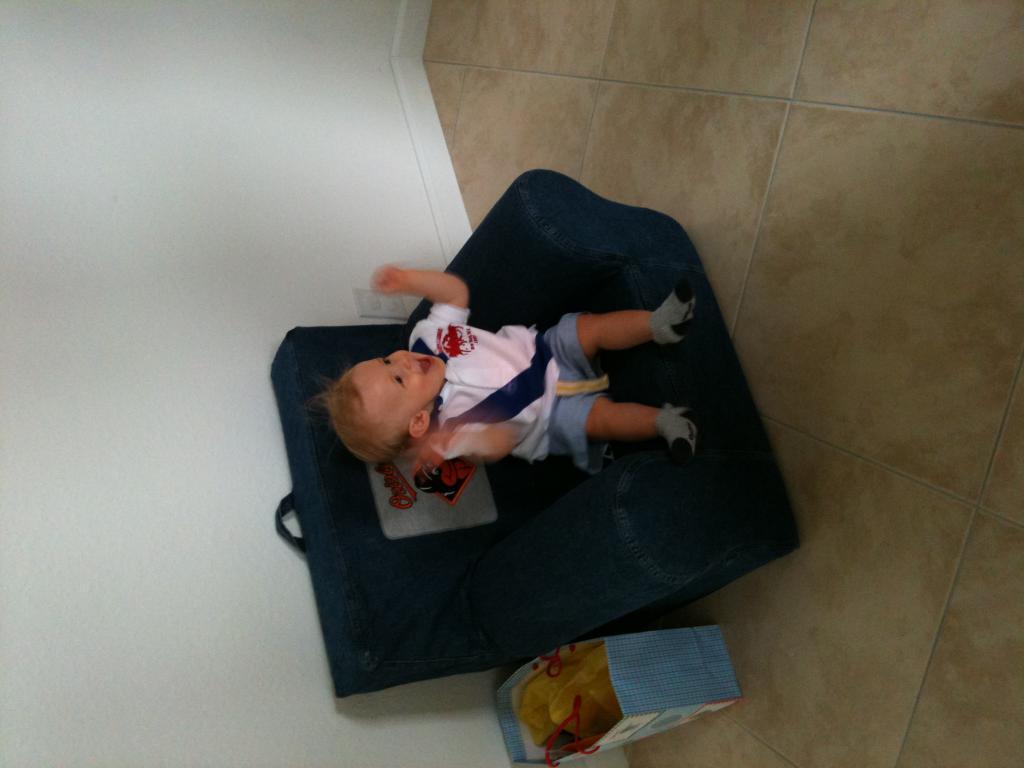In one or two sentences, can you explain what this image depicts? In the picture we can see a small baby on the chair and beside the chair we can see a bag. 